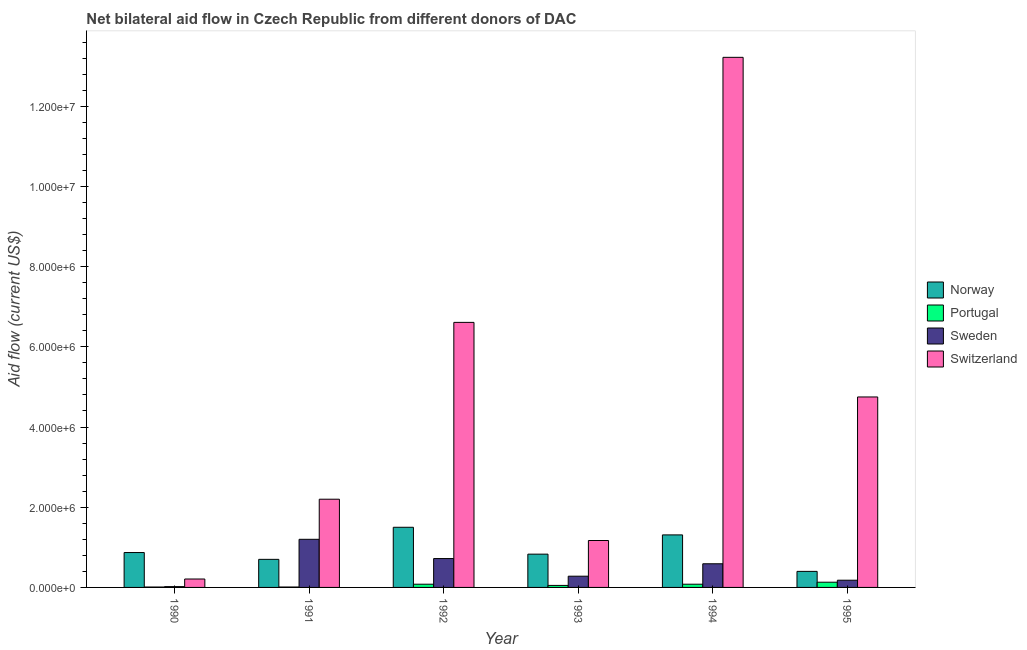How many different coloured bars are there?
Provide a succinct answer. 4. How many groups of bars are there?
Give a very brief answer. 6. In how many cases, is the number of bars for a given year not equal to the number of legend labels?
Provide a succinct answer. 0. What is the amount of aid given by portugal in 1995?
Ensure brevity in your answer.  1.30e+05. Across all years, what is the maximum amount of aid given by sweden?
Give a very brief answer. 1.20e+06. Across all years, what is the minimum amount of aid given by switzerland?
Your answer should be compact. 2.10e+05. In which year was the amount of aid given by portugal maximum?
Offer a terse response. 1995. What is the total amount of aid given by portugal in the graph?
Offer a terse response. 3.60e+05. What is the difference between the amount of aid given by switzerland in 1991 and that in 1995?
Your response must be concise. -2.55e+06. What is the difference between the amount of aid given by switzerland in 1995 and the amount of aid given by portugal in 1990?
Ensure brevity in your answer.  4.54e+06. What is the average amount of aid given by switzerland per year?
Offer a very short reply. 4.69e+06. In how many years, is the amount of aid given by sweden greater than 2000000 US$?
Keep it short and to the point. 0. What is the ratio of the amount of aid given by norway in 1990 to that in 1995?
Ensure brevity in your answer.  2.17. Is the amount of aid given by sweden in 1990 less than that in 1995?
Provide a succinct answer. Yes. Is the difference between the amount of aid given by sweden in 1994 and 1995 greater than the difference between the amount of aid given by switzerland in 1994 and 1995?
Your answer should be very brief. No. What is the difference between the highest and the lowest amount of aid given by sweden?
Your response must be concise. 1.18e+06. In how many years, is the amount of aid given by portugal greater than the average amount of aid given by portugal taken over all years?
Provide a succinct answer. 3. Is it the case that in every year, the sum of the amount of aid given by switzerland and amount of aid given by portugal is greater than the sum of amount of aid given by sweden and amount of aid given by norway?
Your response must be concise. No. What does the 1st bar from the left in 1994 represents?
Offer a very short reply. Norway. What does the 1st bar from the right in 1993 represents?
Offer a terse response. Switzerland. How many bars are there?
Your answer should be very brief. 24. Are all the bars in the graph horizontal?
Keep it short and to the point. No. How many years are there in the graph?
Your response must be concise. 6. What is the difference between two consecutive major ticks on the Y-axis?
Provide a short and direct response. 2.00e+06. Does the graph contain any zero values?
Your response must be concise. No. What is the title of the graph?
Ensure brevity in your answer.  Net bilateral aid flow in Czech Republic from different donors of DAC. Does "Portugal" appear as one of the legend labels in the graph?
Ensure brevity in your answer.  Yes. What is the label or title of the X-axis?
Provide a short and direct response. Year. What is the label or title of the Y-axis?
Keep it short and to the point. Aid flow (current US$). What is the Aid flow (current US$) of Norway in 1990?
Your answer should be very brief. 8.70e+05. What is the Aid flow (current US$) in Portugal in 1991?
Your answer should be very brief. 10000. What is the Aid flow (current US$) in Sweden in 1991?
Provide a succinct answer. 1.20e+06. What is the Aid flow (current US$) of Switzerland in 1991?
Provide a short and direct response. 2.20e+06. What is the Aid flow (current US$) in Norway in 1992?
Your response must be concise. 1.50e+06. What is the Aid flow (current US$) in Sweden in 1992?
Your answer should be very brief. 7.20e+05. What is the Aid flow (current US$) of Switzerland in 1992?
Provide a short and direct response. 6.61e+06. What is the Aid flow (current US$) of Norway in 1993?
Make the answer very short. 8.30e+05. What is the Aid flow (current US$) in Portugal in 1993?
Ensure brevity in your answer.  5.00e+04. What is the Aid flow (current US$) in Switzerland in 1993?
Provide a succinct answer. 1.17e+06. What is the Aid flow (current US$) in Norway in 1994?
Your answer should be compact. 1.31e+06. What is the Aid flow (current US$) in Portugal in 1994?
Keep it short and to the point. 8.00e+04. What is the Aid flow (current US$) in Sweden in 1994?
Keep it short and to the point. 5.90e+05. What is the Aid flow (current US$) of Switzerland in 1994?
Your response must be concise. 1.32e+07. What is the Aid flow (current US$) in Sweden in 1995?
Provide a short and direct response. 1.80e+05. What is the Aid flow (current US$) in Switzerland in 1995?
Provide a short and direct response. 4.75e+06. Across all years, what is the maximum Aid flow (current US$) of Norway?
Ensure brevity in your answer.  1.50e+06. Across all years, what is the maximum Aid flow (current US$) in Portugal?
Offer a terse response. 1.30e+05. Across all years, what is the maximum Aid flow (current US$) of Sweden?
Your answer should be compact. 1.20e+06. Across all years, what is the maximum Aid flow (current US$) in Switzerland?
Your response must be concise. 1.32e+07. Across all years, what is the minimum Aid flow (current US$) in Norway?
Offer a very short reply. 4.00e+05. What is the total Aid flow (current US$) of Norway in the graph?
Make the answer very short. 5.61e+06. What is the total Aid flow (current US$) in Sweden in the graph?
Provide a short and direct response. 2.99e+06. What is the total Aid flow (current US$) in Switzerland in the graph?
Your answer should be very brief. 2.82e+07. What is the difference between the Aid flow (current US$) in Norway in 1990 and that in 1991?
Provide a succinct answer. 1.70e+05. What is the difference between the Aid flow (current US$) in Sweden in 1990 and that in 1991?
Your response must be concise. -1.18e+06. What is the difference between the Aid flow (current US$) of Switzerland in 1990 and that in 1991?
Provide a succinct answer. -1.99e+06. What is the difference between the Aid flow (current US$) in Norway in 1990 and that in 1992?
Offer a very short reply. -6.30e+05. What is the difference between the Aid flow (current US$) in Portugal in 1990 and that in 1992?
Give a very brief answer. -7.00e+04. What is the difference between the Aid flow (current US$) in Sweden in 1990 and that in 1992?
Provide a succinct answer. -7.00e+05. What is the difference between the Aid flow (current US$) of Switzerland in 1990 and that in 1992?
Give a very brief answer. -6.40e+06. What is the difference between the Aid flow (current US$) of Norway in 1990 and that in 1993?
Provide a succinct answer. 4.00e+04. What is the difference between the Aid flow (current US$) in Portugal in 1990 and that in 1993?
Your response must be concise. -4.00e+04. What is the difference between the Aid flow (current US$) of Switzerland in 1990 and that in 1993?
Provide a succinct answer. -9.60e+05. What is the difference between the Aid flow (current US$) in Norway in 1990 and that in 1994?
Offer a terse response. -4.40e+05. What is the difference between the Aid flow (current US$) in Portugal in 1990 and that in 1994?
Offer a terse response. -7.00e+04. What is the difference between the Aid flow (current US$) in Sweden in 1990 and that in 1994?
Provide a succinct answer. -5.70e+05. What is the difference between the Aid flow (current US$) in Switzerland in 1990 and that in 1994?
Keep it short and to the point. -1.30e+07. What is the difference between the Aid flow (current US$) in Switzerland in 1990 and that in 1995?
Provide a succinct answer. -4.54e+06. What is the difference between the Aid flow (current US$) in Norway in 1991 and that in 1992?
Your response must be concise. -8.00e+05. What is the difference between the Aid flow (current US$) of Switzerland in 1991 and that in 1992?
Offer a very short reply. -4.41e+06. What is the difference between the Aid flow (current US$) in Norway in 1991 and that in 1993?
Give a very brief answer. -1.30e+05. What is the difference between the Aid flow (current US$) of Sweden in 1991 and that in 1993?
Offer a very short reply. 9.20e+05. What is the difference between the Aid flow (current US$) of Switzerland in 1991 and that in 1993?
Your response must be concise. 1.03e+06. What is the difference between the Aid flow (current US$) in Norway in 1991 and that in 1994?
Make the answer very short. -6.10e+05. What is the difference between the Aid flow (current US$) of Portugal in 1991 and that in 1994?
Offer a very short reply. -7.00e+04. What is the difference between the Aid flow (current US$) of Sweden in 1991 and that in 1994?
Keep it short and to the point. 6.10e+05. What is the difference between the Aid flow (current US$) of Switzerland in 1991 and that in 1994?
Offer a terse response. -1.10e+07. What is the difference between the Aid flow (current US$) of Portugal in 1991 and that in 1995?
Make the answer very short. -1.20e+05. What is the difference between the Aid flow (current US$) in Sweden in 1991 and that in 1995?
Provide a short and direct response. 1.02e+06. What is the difference between the Aid flow (current US$) of Switzerland in 1991 and that in 1995?
Provide a succinct answer. -2.55e+06. What is the difference between the Aid flow (current US$) of Norway in 1992 and that in 1993?
Your answer should be very brief. 6.70e+05. What is the difference between the Aid flow (current US$) in Switzerland in 1992 and that in 1993?
Offer a terse response. 5.44e+06. What is the difference between the Aid flow (current US$) in Norway in 1992 and that in 1994?
Your answer should be very brief. 1.90e+05. What is the difference between the Aid flow (current US$) of Switzerland in 1992 and that in 1994?
Give a very brief answer. -6.61e+06. What is the difference between the Aid flow (current US$) of Norway in 1992 and that in 1995?
Offer a very short reply. 1.10e+06. What is the difference between the Aid flow (current US$) of Portugal in 1992 and that in 1995?
Your response must be concise. -5.00e+04. What is the difference between the Aid flow (current US$) in Sweden in 1992 and that in 1995?
Give a very brief answer. 5.40e+05. What is the difference between the Aid flow (current US$) of Switzerland in 1992 and that in 1995?
Make the answer very short. 1.86e+06. What is the difference between the Aid flow (current US$) in Norway in 1993 and that in 1994?
Offer a very short reply. -4.80e+05. What is the difference between the Aid flow (current US$) in Sweden in 1993 and that in 1994?
Give a very brief answer. -3.10e+05. What is the difference between the Aid flow (current US$) in Switzerland in 1993 and that in 1994?
Your answer should be compact. -1.20e+07. What is the difference between the Aid flow (current US$) of Portugal in 1993 and that in 1995?
Ensure brevity in your answer.  -8.00e+04. What is the difference between the Aid flow (current US$) of Sweden in 1993 and that in 1995?
Your response must be concise. 1.00e+05. What is the difference between the Aid flow (current US$) in Switzerland in 1993 and that in 1995?
Provide a short and direct response. -3.58e+06. What is the difference between the Aid flow (current US$) in Norway in 1994 and that in 1995?
Give a very brief answer. 9.10e+05. What is the difference between the Aid flow (current US$) in Portugal in 1994 and that in 1995?
Provide a succinct answer. -5.00e+04. What is the difference between the Aid flow (current US$) in Sweden in 1994 and that in 1995?
Your response must be concise. 4.10e+05. What is the difference between the Aid flow (current US$) of Switzerland in 1994 and that in 1995?
Provide a succinct answer. 8.47e+06. What is the difference between the Aid flow (current US$) in Norway in 1990 and the Aid flow (current US$) in Portugal in 1991?
Make the answer very short. 8.60e+05. What is the difference between the Aid flow (current US$) in Norway in 1990 and the Aid flow (current US$) in Sweden in 1991?
Offer a terse response. -3.30e+05. What is the difference between the Aid flow (current US$) in Norway in 1990 and the Aid flow (current US$) in Switzerland in 1991?
Make the answer very short. -1.33e+06. What is the difference between the Aid flow (current US$) in Portugal in 1990 and the Aid flow (current US$) in Sweden in 1991?
Your answer should be compact. -1.19e+06. What is the difference between the Aid flow (current US$) of Portugal in 1990 and the Aid flow (current US$) of Switzerland in 1991?
Provide a short and direct response. -2.19e+06. What is the difference between the Aid flow (current US$) in Sweden in 1990 and the Aid flow (current US$) in Switzerland in 1991?
Your answer should be compact. -2.18e+06. What is the difference between the Aid flow (current US$) in Norway in 1990 and the Aid flow (current US$) in Portugal in 1992?
Your response must be concise. 7.90e+05. What is the difference between the Aid flow (current US$) in Norway in 1990 and the Aid flow (current US$) in Sweden in 1992?
Keep it short and to the point. 1.50e+05. What is the difference between the Aid flow (current US$) in Norway in 1990 and the Aid flow (current US$) in Switzerland in 1992?
Your response must be concise. -5.74e+06. What is the difference between the Aid flow (current US$) of Portugal in 1990 and the Aid flow (current US$) of Sweden in 1992?
Keep it short and to the point. -7.10e+05. What is the difference between the Aid flow (current US$) of Portugal in 1990 and the Aid flow (current US$) of Switzerland in 1992?
Your answer should be very brief. -6.60e+06. What is the difference between the Aid flow (current US$) in Sweden in 1990 and the Aid flow (current US$) in Switzerland in 1992?
Keep it short and to the point. -6.59e+06. What is the difference between the Aid flow (current US$) in Norway in 1990 and the Aid flow (current US$) in Portugal in 1993?
Your answer should be very brief. 8.20e+05. What is the difference between the Aid flow (current US$) in Norway in 1990 and the Aid flow (current US$) in Sweden in 1993?
Make the answer very short. 5.90e+05. What is the difference between the Aid flow (current US$) in Portugal in 1990 and the Aid flow (current US$) in Sweden in 1993?
Your answer should be compact. -2.70e+05. What is the difference between the Aid flow (current US$) in Portugal in 1990 and the Aid flow (current US$) in Switzerland in 1993?
Your answer should be very brief. -1.16e+06. What is the difference between the Aid flow (current US$) in Sweden in 1990 and the Aid flow (current US$) in Switzerland in 1993?
Give a very brief answer. -1.15e+06. What is the difference between the Aid flow (current US$) in Norway in 1990 and the Aid flow (current US$) in Portugal in 1994?
Provide a succinct answer. 7.90e+05. What is the difference between the Aid flow (current US$) of Norway in 1990 and the Aid flow (current US$) of Sweden in 1994?
Provide a short and direct response. 2.80e+05. What is the difference between the Aid flow (current US$) of Norway in 1990 and the Aid flow (current US$) of Switzerland in 1994?
Keep it short and to the point. -1.24e+07. What is the difference between the Aid flow (current US$) in Portugal in 1990 and the Aid flow (current US$) in Sweden in 1994?
Ensure brevity in your answer.  -5.80e+05. What is the difference between the Aid flow (current US$) of Portugal in 1990 and the Aid flow (current US$) of Switzerland in 1994?
Offer a terse response. -1.32e+07. What is the difference between the Aid flow (current US$) of Sweden in 1990 and the Aid flow (current US$) of Switzerland in 1994?
Your response must be concise. -1.32e+07. What is the difference between the Aid flow (current US$) of Norway in 1990 and the Aid flow (current US$) of Portugal in 1995?
Give a very brief answer. 7.40e+05. What is the difference between the Aid flow (current US$) of Norway in 1990 and the Aid flow (current US$) of Sweden in 1995?
Ensure brevity in your answer.  6.90e+05. What is the difference between the Aid flow (current US$) of Norway in 1990 and the Aid flow (current US$) of Switzerland in 1995?
Offer a terse response. -3.88e+06. What is the difference between the Aid flow (current US$) of Portugal in 1990 and the Aid flow (current US$) of Switzerland in 1995?
Ensure brevity in your answer.  -4.74e+06. What is the difference between the Aid flow (current US$) in Sweden in 1990 and the Aid flow (current US$) in Switzerland in 1995?
Keep it short and to the point. -4.73e+06. What is the difference between the Aid flow (current US$) of Norway in 1991 and the Aid flow (current US$) of Portugal in 1992?
Your response must be concise. 6.20e+05. What is the difference between the Aid flow (current US$) in Norway in 1991 and the Aid flow (current US$) in Sweden in 1992?
Ensure brevity in your answer.  -2.00e+04. What is the difference between the Aid flow (current US$) of Norway in 1991 and the Aid flow (current US$) of Switzerland in 1992?
Your response must be concise. -5.91e+06. What is the difference between the Aid flow (current US$) in Portugal in 1991 and the Aid flow (current US$) in Sweden in 1992?
Ensure brevity in your answer.  -7.10e+05. What is the difference between the Aid flow (current US$) in Portugal in 1991 and the Aid flow (current US$) in Switzerland in 1992?
Ensure brevity in your answer.  -6.60e+06. What is the difference between the Aid flow (current US$) of Sweden in 1991 and the Aid flow (current US$) of Switzerland in 1992?
Offer a terse response. -5.41e+06. What is the difference between the Aid flow (current US$) in Norway in 1991 and the Aid flow (current US$) in Portugal in 1993?
Offer a very short reply. 6.50e+05. What is the difference between the Aid flow (current US$) in Norway in 1991 and the Aid flow (current US$) in Switzerland in 1993?
Offer a terse response. -4.70e+05. What is the difference between the Aid flow (current US$) of Portugal in 1991 and the Aid flow (current US$) of Sweden in 1993?
Your answer should be compact. -2.70e+05. What is the difference between the Aid flow (current US$) in Portugal in 1991 and the Aid flow (current US$) in Switzerland in 1993?
Offer a very short reply. -1.16e+06. What is the difference between the Aid flow (current US$) in Sweden in 1991 and the Aid flow (current US$) in Switzerland in 1993?
Offer a very short reply. 3.00e+04. What is the difference between the Aid flow (current US$) of Norway in 1991 and the Aid flow (current US$) of Portugal in 1994?
Provide a succinct answer. 6.20e+05. What is the difference between the Aid flow (current US$) of Norway in 1991 and the Aid flow (current US$) of Sweden in 1994?
Your response must be concise. 1.10e+05. What is the difference between the Aid flow (current US$) of Norway in 1991 and the Aid flow (current US$) of Switzerland in 1994?
Offer a very short reply. -1.25e+07. What is the difference between the Aid flow (current US$) of Portugal in 1991 and the Aid flow (current US$) of Sweden in 1994?
Provide a succinct answer. -5.80e+05. What is the difference between the Aid flow (current US$) of Portugal in 1991 and the Aid flow (current US$) of Switzerland in 1994?
Give a very brief answer. -1.32e+07. What is the difference between the Aid flow (current US$) of Sweden in 1991 and the Aid flow (current US$) of Switzerland in 1994?
Keep it short and to the point. -1.20e+07. What is the difference between the Aid flow (current US$) in Norway in 1991 and the Aid flow (current US$) in Portugal in 1995?
Your response must be concise. 5.70e+05. What is the difference between the Aid flow (current US$) of Norway in 1991 and the Aid flow (current US$) of Sweden in 1995?
Provide a short and direct response. 5.20e+05. What is the difference between the Aid flow (current US$) in Norway in 1991 and the Aid flow (current US$) in Switzerland in 1995?
Give a very brief answer. -4.05e+06. What is the difference between the Aid flow (current US$) of Portugal in 1991 and the Aid flow (current US$) of Sweden in 1995?
Offer a terse response. -1.70e+05. What is the difference between the Aid flow (current US$) of Portugal in 1991 and the Aid flow (current US$) of Switzerland in 1995?
Make the answer very short. -4.74e+06. What is the difference between the Aid flow (current US$) of Sweden in 1991 and the Aid flow (current US$) of Switzerland in 1995?
Your answer should be compact. -3.55e+06. What is the difference between the Aid flow (current US$) in Norway in 1992 and the Aid flow (current US$) in Portugal in 1993?
Keep it short and to the point. 1.45e+06. What is the difference between the Aid flow (current US$) in Norway in 1992 and the Aid flow (current US$) in Sweden in 1993?
Your response must be concise. 1.22e+06. What is the difference between the Aid flow (current US$) in Norway in 1992 and the Aid flow (current US$) in Switzerland in 1993?
Your answer should be very brief. 3.30e+05. What is the difference between the Aid flow (current US$) in Portugal in 1992 and the Aid flow (current US$) in Switzerland in 1993?
Your response must be concise. -1.09e+06. What is the difference between the Aid flow (current US$) of Sweden in 1992 and the Aid flow (current US$) of Switzerland in 1993?
Your answer should be very brief. -4.50e+05. What is the difference between the Aid flow (current US$) of Norway in 1992 and the Aid flow (current US$) of Portugal in 1994?
Your answer should be very brief. 1.42e+06. What is the difference between the Aid flow (current US$) of Norway in 1992 and the Aid flow (current US$) of Sweden in 1994?
Your answer should be compact. 9.10e+05. What is the difference between the Aid flow (current US$) in Norway in 1992 and the Aid flow (current US$) in Switzerland in 1994?
Ensure brevity in your answer.  -1.17e+07. What is the difference between the Aid flow (current US$) of Portugal in 1992 and the Aid flow (current US$) of Sweden in 1994?
Provide a short and direct response. -5.10e+05. What is the difference between the Aid flow (current US$) of Portugal in 1992 and the Aid flow (current US$) of Switzerland in 1994?
Keep it short and to the point. -1.31e+07. What is the difference between the Aid flow (current US$) in Sweden in 1992 and the Aid flow (current US$) in Switzerland in 1994?
Your answer should be compact. -1.25e+07. What is the difference between the Aid flow (current US$) of Norway in 1992 and the Aid flow (current US$) of Portugal in 1995?
Make the answer very short. 1.37e+06. What is the difference between the Aid flow (current US$) in Norway in 1992 and the Aid flow (current US$) in Sweden in 1995?
Offer a terse response. 1.32e+06. What is the difference between the Aid flow (current US$) in Norway in 1992 and the Aid flow (current US$) in Switzerland in 1995?
Provide a succinct answer. -3.25e+06. What is the difference between the Aid flow (current US$) in Portugal in 1992 and the Aid flow (current US$) in Sweden in 1995?
Provide a succinct answer. -1.00e+05. What is the difference between the Aid flow (current US$) of Portugal in 1992 and the Aid flow (current US$) of Switzerland in 1995?
Your response must be concise. -4.67e+06. What is the difference between the Aid flow (current US$) of Sweden in 1992 and the Aid flow (current US$) of Switzerland in 1995?
Keep it short and to the point. -4.03e+06. What is the difference between the Aid flow (current US$) of Norway in 1993 and the Aid flow (current US$) of Portugal in 1994?
Keep it short and to the point. 7.50e+05. What is the difference between the Aid flow (current US$) in Norway in 1993 and the Aid flow (current US$) in Switzerland in 1994?
Your answer should be compact. -1.24e+07. What is the difference between the Aid flow (current US$) of Portugal in 1993 and the Aid flow (current US$) of Sweden in 1994?
Offer a terse response. -5.40e+05. What is the difference between the Aid flow (current US$) in Portugal in 1993 and the Aid flow (current US$) in Switzerland in 1994?
Keep it short and to the point. -1.32e+07. What is the difference between the Aid flow (current US$) in Sweden in 1993 and the Aid flow (current US$) in Switzerland in 1994?
Your response must be concise. -1.29e+07. What is the difference between the Aid flow (current US$) in Norway in 1993 and the Aid flow (current US$) in Portugal in 1995?
Give a very brief answer. 7.00e+05. What is the difference between the Aid flow (current US$) of Norway in 1993 and the Aid flow (current US$) of Sweden in 1995?
Give a very brief answer. 6.50e+05. What is the difference between the Aid flow (current US$) of Norway in 1993 and the Aid flow (current US$) of Switzerland in 1995?
Provide a short and direct response. -3.92e+06. What is the difference between the Aid flow (current US$) in Portugal in 1993 and the Aid flow (current US$) in Switzerland in 1995?
Offer a terse response. -4.70e+06. What is the difference between the Aid flow (current US$) in Sweden in 1993 and the Aid flow (current US$) in Switzerland in 1995?
Provide a succinct answer. -4.47e+06. What is the difference between the Aid flow (current US$) in Norway in 1994 and the Aid flow (current US$) in Portugal in 1995?
Ensure brevity in your answer.  1.18e+06. What is the difference between the Aid flow (current US$) of Norway in 1994 and the Aid flow (current US$) of Sweden in 1995?
Your answer should be very brief. 1.13e+06. What is the difference between the Aid flow (current US$) of Norway in 1994 and the Aid flow (current US$) of Switzerland in 1995?
Give a very brief answer. -3.44e+06. What is the difference between the Aid flow (current US$) in Portugal in 1994 and the Aid flow (current US$) in Switzerland in 1995?
Offer a terse response. -4.67e+06. What is the difference between the Aid flow (current US$) in Sweden in 1994 and the Aid flow (current US$) in Switzerland in 1995?
Your answer should be compact. -4.16e+06. What is the average Aid flow (current US$) of Norway per year?
Your answer should be compact. 9.35e+05. What is the average Aid flow (current US$) of Portugal per year?
Offer a very short reply. 6.00e+04. What is the average Aid flow (current US$) of Sweden per year?
Provide a short and direct response. 4.98e+05. What is the average Aid flow (current US$) in Switzerland per year?
Offer a terse response. 4.69e+06. In the year 1990, what is the difference between the Aid flow (current US$) in Norway and Aid flow (current US$) in Portugal?
Your response must be concise. 8.60e+05. In the year 1990, what is the difference between the Aid flow (current US$) of Norway and Aid flow (current US$) of Sweden?
Ensure brevity in your answer.  8.50e+05. In the year 1990, what is the difference between the Aid flow (current US$) in Portugal and Aid flow (current US$) in Sweden?
Provide a short and direct response. -10000. In the year 1990, what is the difference between the Aid flow (current US$) in Sweden and Aid flow (current US$) in Switzerland?
Make the answer very short. -1.90e+05. In the year 1991, what is the difference between the Aid flow (current US$) in Norway and Aid flow (current US$) in Portugal?
Your response must be concise. 6.90e+05. In the year 1991, what is the difference between the Aid flow (current US$) in Norway and Aid flow (current US$) in Sweden?
Ensure brevity in your answer.  -5.00e+05. In the year 1991, what is the difference between the Aid flow (current US$) in Norway and Aid flow (current US$) in Switzerland?
Offer a terse response. -1.50e+06. In the year 1991, what is the difference between the Aid flow (current US$) of Portugal and Aid flow (current US$) of Sweden?
Offer a terse response. -1.19e+06. In the year 1991, what is the difference between the Aid flow (current US$) in Portugal and Aid flow (current US$) in Switzerland?
Your response must be concise. -2.19e+06. In the year 1992, what is the difference between the Aid flow (current US$) in Norway and Aid flow (current US$) in Portugal?
Keep it short and to the point. 1.42e+06. In the year 1992, what is the difference between the Aid flow (current US$) of Norway and Aid flow (current US$) of Sweden?
Provide a short and direct response. 7.80e+05. In the year 1992, what is the difference between the Aid flow (current US$) of Norway and Aid flow (current US$) of Switzerland?
Offer a very short reply. -5.11e+06. In the year 1992, what is the difference between the Aid flow (current US$) in Portugal and Aid flow (current US$) in Sweden?
Give a very brief answer. -6.40e+05. In the year 1992, what is the difference between the Aid flow (current US$) in Portugal and Aid flow (current US$) in Switzerland?
Offer a terse response. -6.53e+06. In the year 1992, what is the difference between the Aid flow (current US$) in Sweden and Aid flow (current US$) in Switzerland?
Your response must be concise. -5.89e+06. In the year 1993, what is the difference between the Aid flow (current US$) in Norway and Aid flow (current US$) in Portugal?
Make the answer very short. 7.80e+05. In the year 1993, what is the difference between the Aid flow (current US$) in Norway and Aid flow (current US$) in Switzerland?
Offer a terse response. -3.40e+05. In the year 1993, what is the difference between the Aid flow (current US$) of Portugal and Aid flow (current US$) of Sweden?
Give a very brief answer. -2.30e+05. In the year 1993, what is the difference between the Aid flow (current US$) in Portugal and Aid flow (current US$) in Switzerland?
Your answer should be very brief. -1.12e+06. In the year 1993, what is the difference between the Aid flow (current US$) of Sweden and Aid flow (current US$) of Switzerland?
Ensure brevity in your answer.  -8.90e+05. In the year 1994, what is the difference between the Aid flow (current US$) of Norway and Aid flow (current US$) of Portugal?
Your answer should be very brief. 1.23e+06. In the year 1994, what is the difference between the Aid flow (current US$) of Norway and Aid flow (current US$) of Sweden?
Keep it short and to the point. 7.20e+05. In the year 1994, what is the difference between the Aid flow (current US$) in Norway and Aid flow (current US$) in Switzerland?
Ensure brevity in your answer.  -1.19e+07. In the year 1994, what is the difference between the Aid flow (current US$) in Portugal and Aid flow (current US$) in Sweden?
Your answer should be compact. -5.10e+05. In the year 1994, what is the difference between the Aid flow (current US$) of Portugal and Aid flow (current US$) of Switzerland?
Your response must be concise. -1.31e+07. In the year 1994, what is the difference between the Aid flow (current US$) in Sweden and Aid flow (current US$) in Switzerland?
Keep it short and to the point. -1.26e+07. In the year 1995, what is the difference between the Aid flow (current US$) of Norway and Aid flow (current US$) of Sweden?
Offer a terse response. 2.20e+05. In the year 1995, what is the difference between the Aid flow (current US$) of Norway and Aid flow (current US$) of Switzerland?
Your response must be concise. -4.35e+06. In the year 1995, what is the difference between the Aid flow (current US$) of Portugal and Aid flow (current US$) of Sweden?
Your answer should be compact. -5.00e+04. In the year 1995, what is the difference between the Aid flow (current US$) of Portugal and Aid flow (current US$) of Switzerland?
Offer a very short reply. -4.62e+06. In the year 1995, what is the difference between the Aid flow (current US$) of Sweden and Aid flow (current US$) of Switzerland?
Give a very brief answer. -4.57e+06. What is the ratio of the Aid flow (current US$) of Norway in 1990 to that in 1991?
Your response must be concise. 1.24. What is the ratio of the Aid flow (current US$) in Sweden in 1990 to that in 1991?
Keep it short and to the point. 0.02. What is the ratio of the Aid flow (current US$) of Switzerland in 1990 to that in 1991?
Offer a terse response. 0.1. What is the ratio of the Aid flow (current US$) of Norway in 1990 to that in 1992?
Your answer should be very brief. 0.58. What is the ratio of the Aid flow (current US$) in Sweden in 1990 to that in 1992?
Ensure brevity in your answer.  0.03. What is the ratio of the Aid flow (current US$) in Switzerland in 1990 to that in 1992?
Make the answer very short. 0.03. What is the ratio of the Aid flow (current US$) of Norway in 1990 to that in 1993?
Provide a short and direct response. 1.05. What is the ratio of the Aid flow (current US$) of Portugal in 1990 to that in 1993?
Make the answer very short. 0.2. What is the ratio of the Aid flow (current US$) in Sweden in 1990 to that in 1993?
Ensure brevity in your answer.  0.07. What is the ratio of the Aid flow (current US$) in Switzerland in 1990 to that in 1993?
Your response must be concise. 0.18. What is the ratio of the Aid flow (current US$) of Norway in 1990 to that in 1994?
Keep it short and to the point. 0.66. What is the ratio of the Aid flow (current US$) in Portugal in 1990 to that in 1994?
Ensure brevity in your answer.  0.12. What is the ratio of the Aid flow (current US$) of Sweden in 1990 to that in 1994?
Offer a terse response. 0.03. What is the ratio of the Aid flow (current US$) in Switzerland in 1990 to that in 1994?
Offer a very short reply. 0.02. What is the ratio of the Aid flow (current US$) in Norway in 1990 to that in 1995?
Offer a terse response. 2.17. What is the ratio of the Aid flow (current US$) of Portugal in 1990 to that in 1995?
Offer a terse response. 0.08. What is the ratio of the Aid flow (current US$) of Sweden in 1990 to that in 1995?
Ensure brevity in your answer.  0.11. What is the ratio of the Aid flow (current US$) of Switzerland in 1990 to that in 1995?
Give a very brief answer. 0.04. What is the ratio of the Aid flow (current US$) in Norway in 1991 to that in 1992?
Provide a succinct answer. 0.47. What is the ratio of the Aid flow (current US$) of Portugal in 1991 to that in 1992?
Ensure brevity in your answer.  0.12. What is the ratio of the Aid flow (current US$) of Switzerland in 1991 to that in 1992?
Provide a succinct answer. 0.33. What is the ratio of the Aid flow (current US$) of Norway in 1991 to that in 1993?
Make the answer very short. 0.84. What is the ratio of the Aid flow (current US$) in Portugal in 1991 to that in 1993?
Give a very brief answer. 0.2. What is the ratio of the Aid flow (current US$) of Sweden in 1991 to that in 1993?
Your response must be concise. 4.29. What is the ratio of the Aid flow (current US$) of Switzerland in 1991 to that in 1993?
Provide a succinct answer. 1.88. What is the ratio of the Aid flow (current US$) of Norway in 1991 to that in 1994?
Keep it short and to the point. 0.53. What is the ratio of the Aid flow (current US$) in Portugal in 1991 to that in 1994?
Make the answer very short. 0.12. What is the ratio of the Aid flow (current US$) in Sweden in 1991 to that in 1994?
Provide a succinct answer. 2.03. What is the ratio of the Aid flow (current US$) of Switzerland in 1991 to that in 1994?
Your response must be concise. 0.17. What is the ratio of the Aid flow (current US$) of Portugal in 1991 to that in 1995?
Your response must be concise. 0.08. What is the ratio of the Aid flow (current US$) in Sweden in 1991 to that in 1995?
Your answer should be very brief. 6.67. What is the ratio of the Aid flow (current US$) in Switzerland in 1991 to that in 1995?
Give a very brief answer. 0.46. What is the ratio of the Aid flow (current US$) of Norway in 1992 to that in 1993?
Your answer should be compact. 1.81. What is the ratio of the Aid flow (current US$) of Sweden in 1992 to that in 1993?
Give a very brief answer. 2.57. What is the ratio of the Aid flow (current US$) of Switzerland in 1992 to that in 1993?
Give a very brief answer. 5.65. What is the ratio of the Aid flow (current US$) in Norway in 1992 to that in 1994?
Your response must be concise. 1.15. What is the ratio of the Aid flow (current US$) of Portugal in 1992 to that in 1994?
Your answer should be compact. 1. What is the ratio of the Aid flow (current US$) in Sweden in 1992 to that in 1994?
Your answer should be very brief. 1.22. What is the ratio of the Aid flow (current US$) of Switzerland in 1992 to that in 1994?
Provide a succinct answer. 0.5. What is the ratio of the Aid flow (current US$) of Norway in 1992 to that in 1995?
Your answer should be very brief. 3.75. What is the ratio of the Aid flow (current US$) of Portugal in 1992 to that in 1995?
Your answer should be compact. 0.62. What is the ratio of the Aid flow (current US$) in Switzerland in 1992 to that in 1995?
Your response must be concise. 1.39. What is the ratio of the Aid flow (current US$) of Norway in 1993 to that in 1994?
Your answer should be compact. 0.63. What is the ratio of the Aid flow (current US$) in Portugal in 1993 to that in 1994?
Keep it short and to the point. 0.62. What is the ratio of the Aid flow (current US$) in Sweden in 1993 to that in 1994?
Your answer should be very brief. 0.47. What is the ratio of the Aid flow (current US$) of Switzerland in 1993 to that in 1994?
Keep it short and to the point. 0.09. What is the ratio of the Aid flow (current US$) in Norway in 1993 to that in 1995?
Your answer should be very brief. 2.08. What is the ratio of the Aid flow (current US$) of Portugal in 1993 to that in 1995?
Your response must be concise. 0.38. What is the ratio of the Aid flow (current US$) of Sweden in 1993 to that in 1995?
Provide a short and direct response. 1.56. What is the ratio of the Aid flow (current US$) in Switzerland in 1993 to that in 1995?
Your answer should be very brief. 0.25. What is the ratio of the Aid flow (current US$) in Norway in 1994 to that in 1995?
Provide a succinct answer. 3.27. What is the ratio of the Aid flow (current US$) in Portugal in 1994 to that in 1995?
Provide a short and direct response. 0.62. What is the ratio of the Aid flow (current US$) of Sweden in 1994 to that in 1995?
Provide a succinct answer. 3.28. What is the ratio of the Aid flow (current US$) of Switzerland in 1994 to that in 1995?
Your response must be concise. 2.78. What is the difference between the highest and the second highest Aid flow (current US$) in Sweden?
Provide a short and direct response. 4.80e+05. What is the difference between the highest and the second highest Aid flow (current US$) of Switzerland?
Your response must be concise. 6.61e+06. What is the difference between the highest and the lowest Aid flow (current US$) of Norway?
Ensure brevity in your answer.  1.10e+06. What is the difference between the highest and the lowest Aid flow (current US$) in Sweden?
Ensure brevity in your answer.  1.18e+06. What is the difference between the highest and the lowest Aid flow (current US$) of Switzerland?
Ensure brevity in your answer.  1.30e+07. 